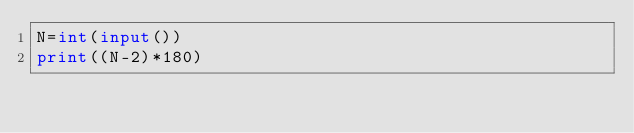<code> <loc_0><loc_0><loc_500><loc_500><_Python_>N=int(input())
print((N-2)*180)</code> 